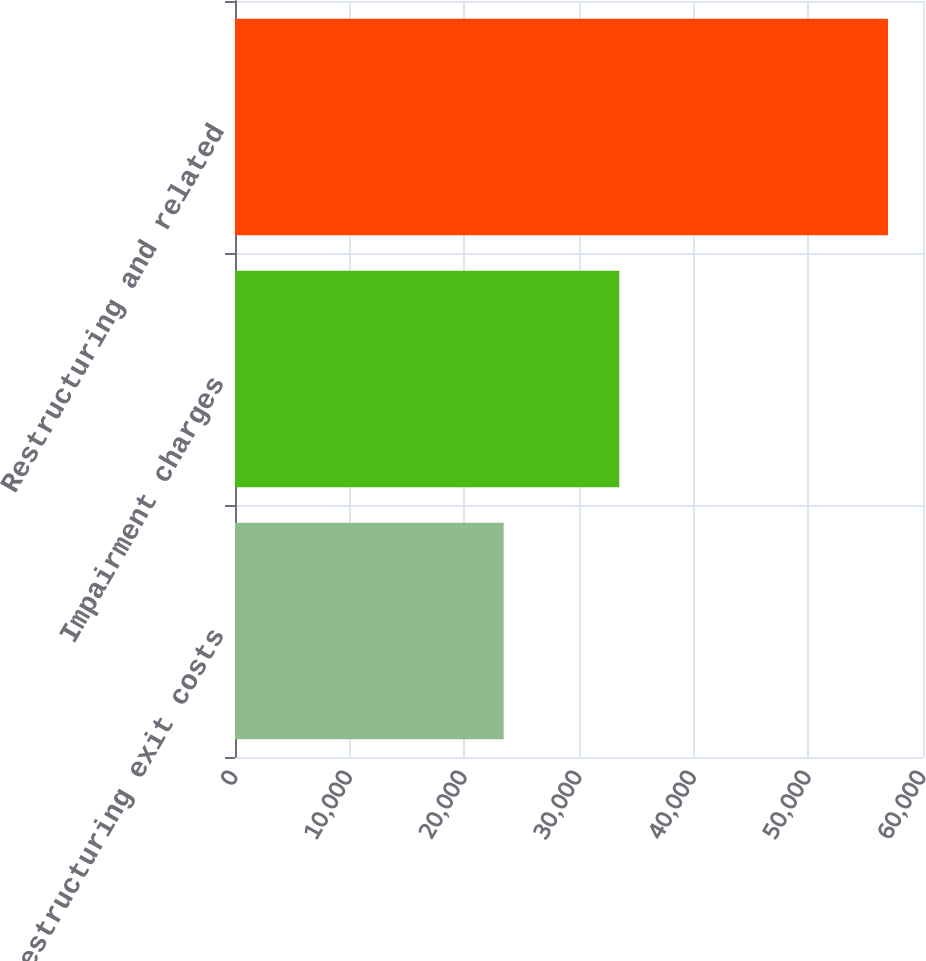Convert chart to OTSL. <chart><loc_0><loc_0><loc_500><loc_500><bar_chart><fcel>Restructuring exit costs<fcel>Impairment charges<fcel>Restructuring and related<nl><fcel>23432<fcel>33514<fcel>56946<nl></chart> 